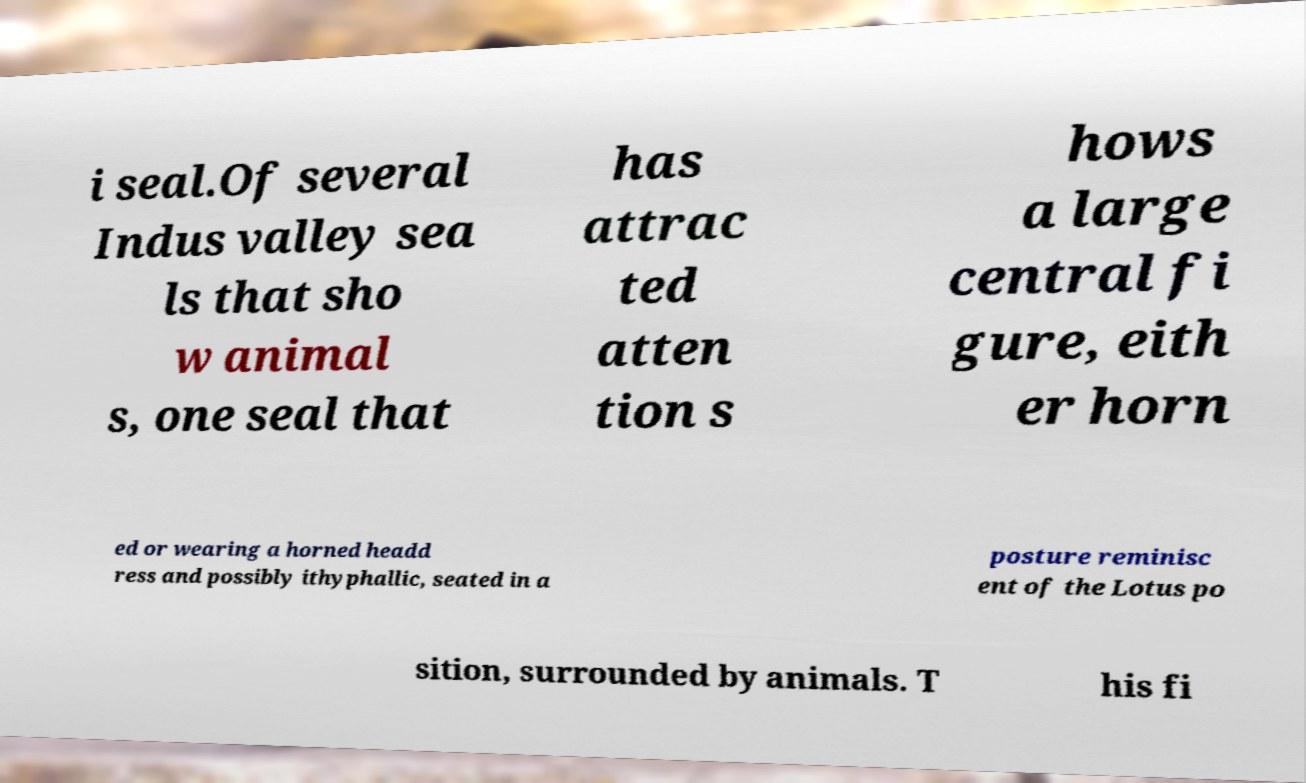Could you extract and type out the text from this image? i seal.Of several Indus valley sea ls that sho w animal s, one seal that has attrac ted atten tion s hows a large central fi gure, eith er horn ed or wearing a horned headd ress and possibly ithyphallic, seated in a posture reminisc ent of the Lotus po sition, surrounded by animals. T his fi 